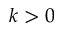<formula> <loc_0><loc_0><loc_500><loc_500>k > 0</formula> 